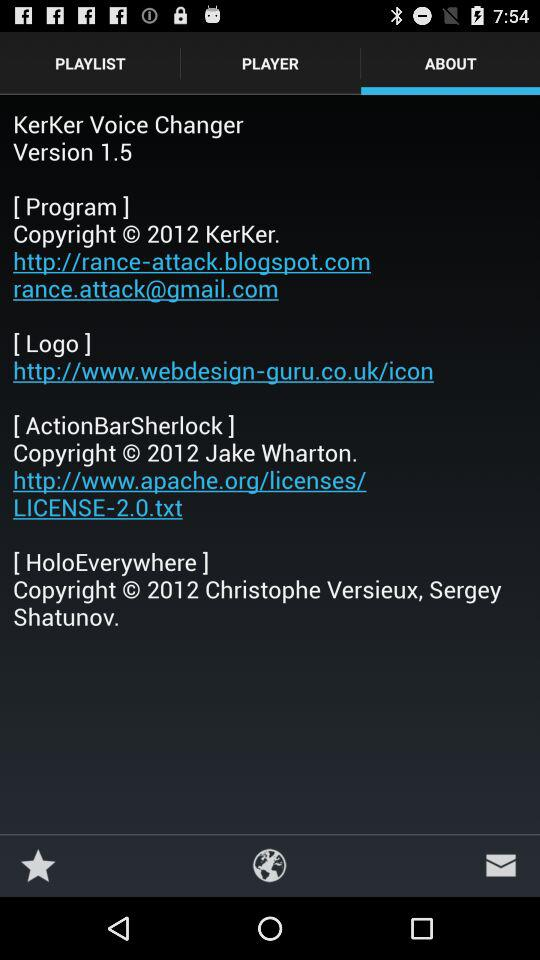Which option is selected? The option "ABOUT" is selected. 